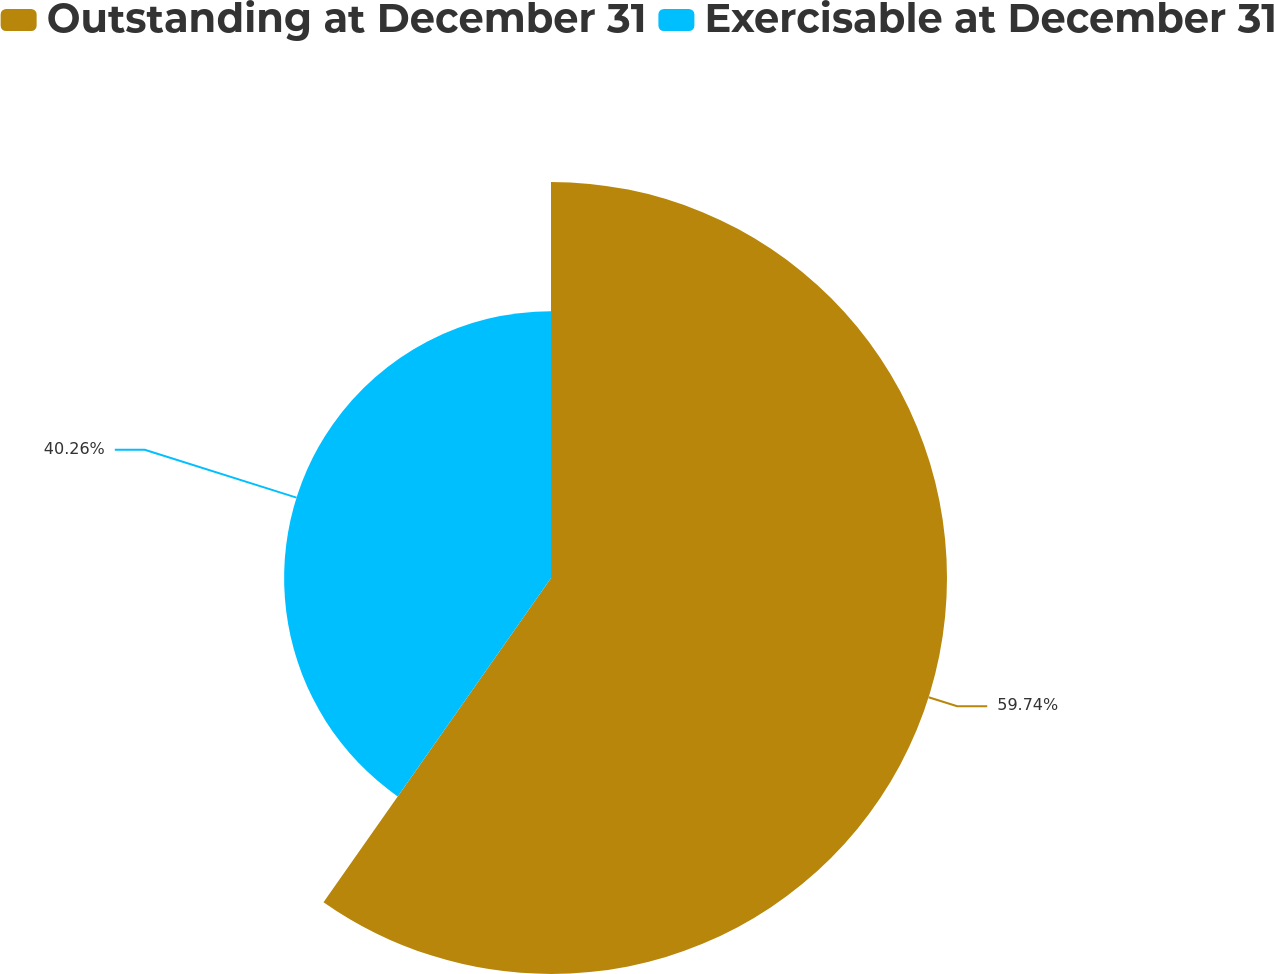Convert chart. <chart><loc_0><loc_0><loc_500><loc_500><pie_chart><fcel>Outstanding at December 31<fcel>Exercisable at December 31<nl><fcel>59.74%<fcel>40.26%<nl></chart> 